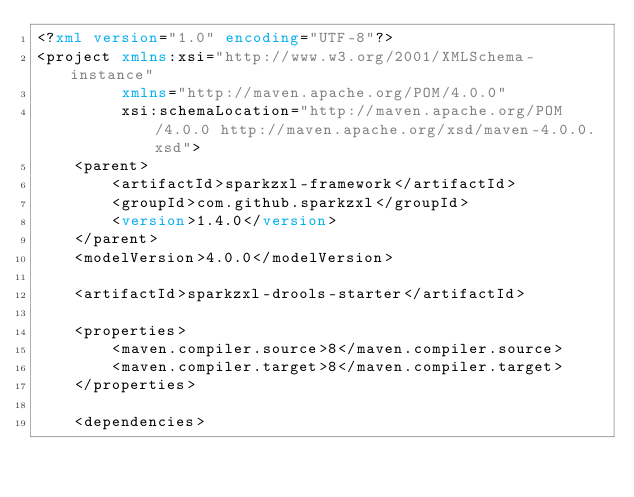Convert code to text. <code><loc_0><loc_0><loc_500><loc_500><_XML_><?xml version="1.0" encoding="UTF-8"?>
<project xmlns:xsi="http://www.w3.org/2001/XMLSchema-instance"
         xmlns="http://maven.apache.org/POM/4.0.0"
         xsi:schemaLocation="http://maven.apache.org/POM/4.0.0 http://maven.apache.org/xsd/maven-4.0.0.xsd">
    <parent>
        <artifactId>sparkzxl-framework</artifactId>
        <groupId>com.github.sparkzxl</groupId>
        <version>1.4.0</version>
    </parent>
    <modelVersion>4.0.0</modelVersion>

    <artifactId>sparkzxl-drools-starter</artifactId>

    <properties>
        <maven.compiler.source>8</maven.compiler.source>
        <maven.compiler.target>8</maven.compiler.target>
    </properties>

    <dependencies></code> 